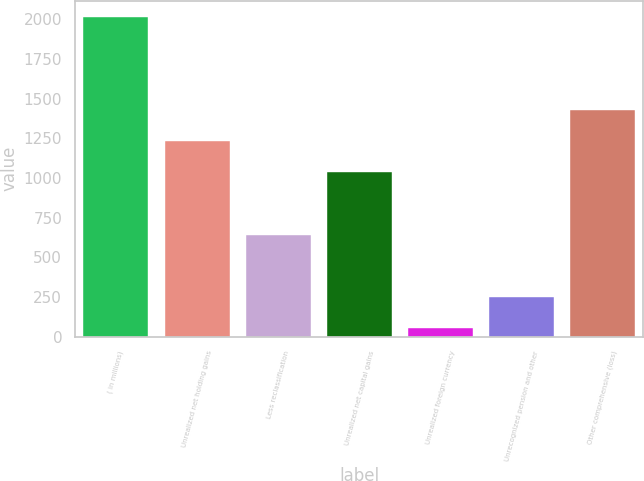<chart> <loc_0><loc_0><loc_500><loc_500><bar_chart><fcel>( in millions)<fcel>Unrealized net holding gains<fcel>Less reclassification<fcel>Unrealized net capital gains<fcel>Unrealized foreign currency<fcel>Unrecognized pension and other<fcel>Other comprehensive (loss)<nl><fcel>2018<fcel>1232.8<fcel>643.9<fcel>1036.5<fcel>55<fcel>251.3<fcel>1429.1<nl></chart> 